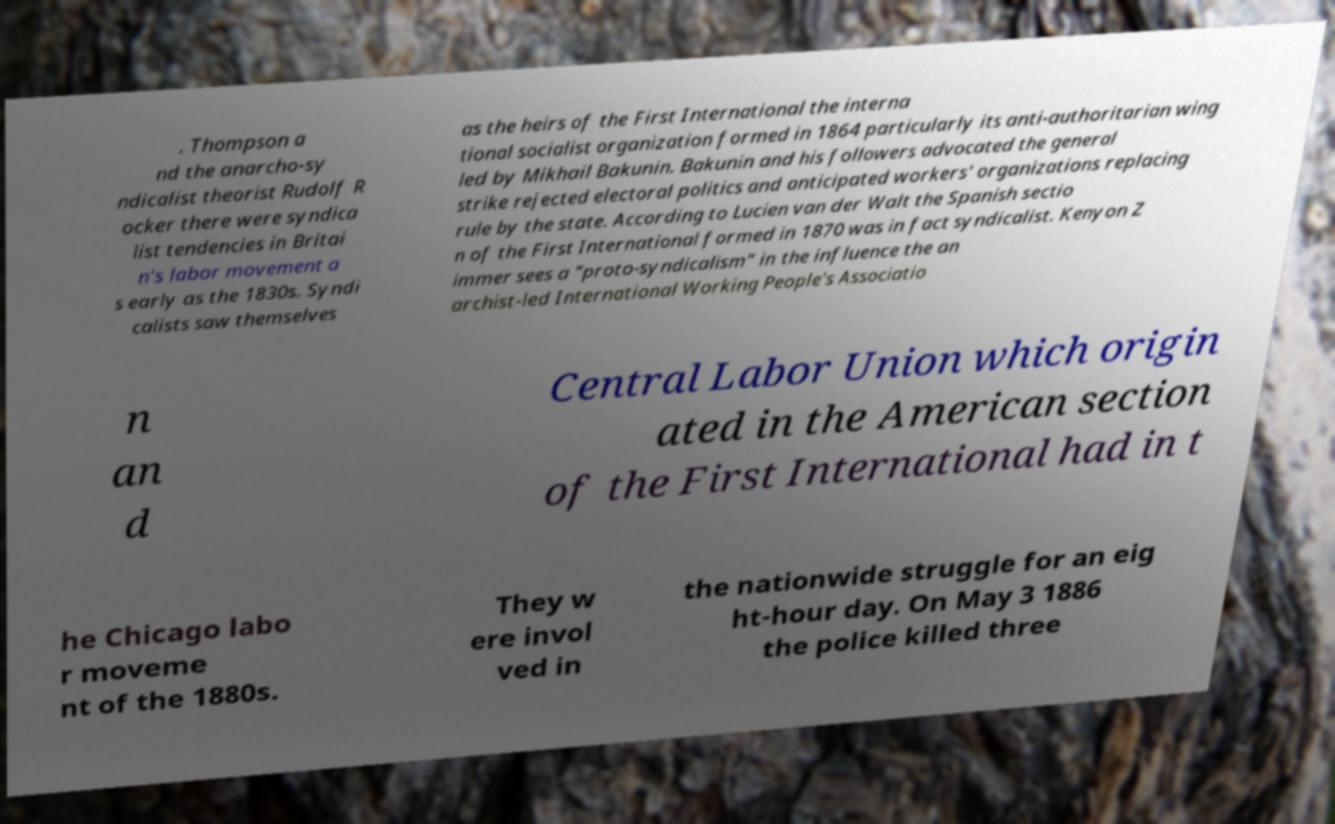Could you assist in decoding the text presented in this image and type it out clearly? . Thompson a nd the anarcho-sy ndicalist theorist Rudolf R ocker there were syndica list tendencies in Britai n's labor movement a s early as the 1830s. Syndi calists saw themselves as the heirs of the First International the interna tional socialist organization formed in 1864 particularly its anti-authoritarian wing led by Mikhail Bakunin. Bakunin and his followers advocated the general strike rejected electoral politics and anticipated workers' organizations replacing rule by the state. According to Lucien van der Walt the Spanish sectio n of the First International formed in 1870 was in fact syndicalist. Kenyon Z immer sees a "proto-syndicalism" in the influence the an archist-led International Working People's Associatio n an d Central Labor Union which origin ated in the American section of the First International had in t he Chicago labo r moveme nt of the 1880s. They w ere invol ved in the nationwide struggle for an eig ht-hour day. On May 3 1886 the police killed three 